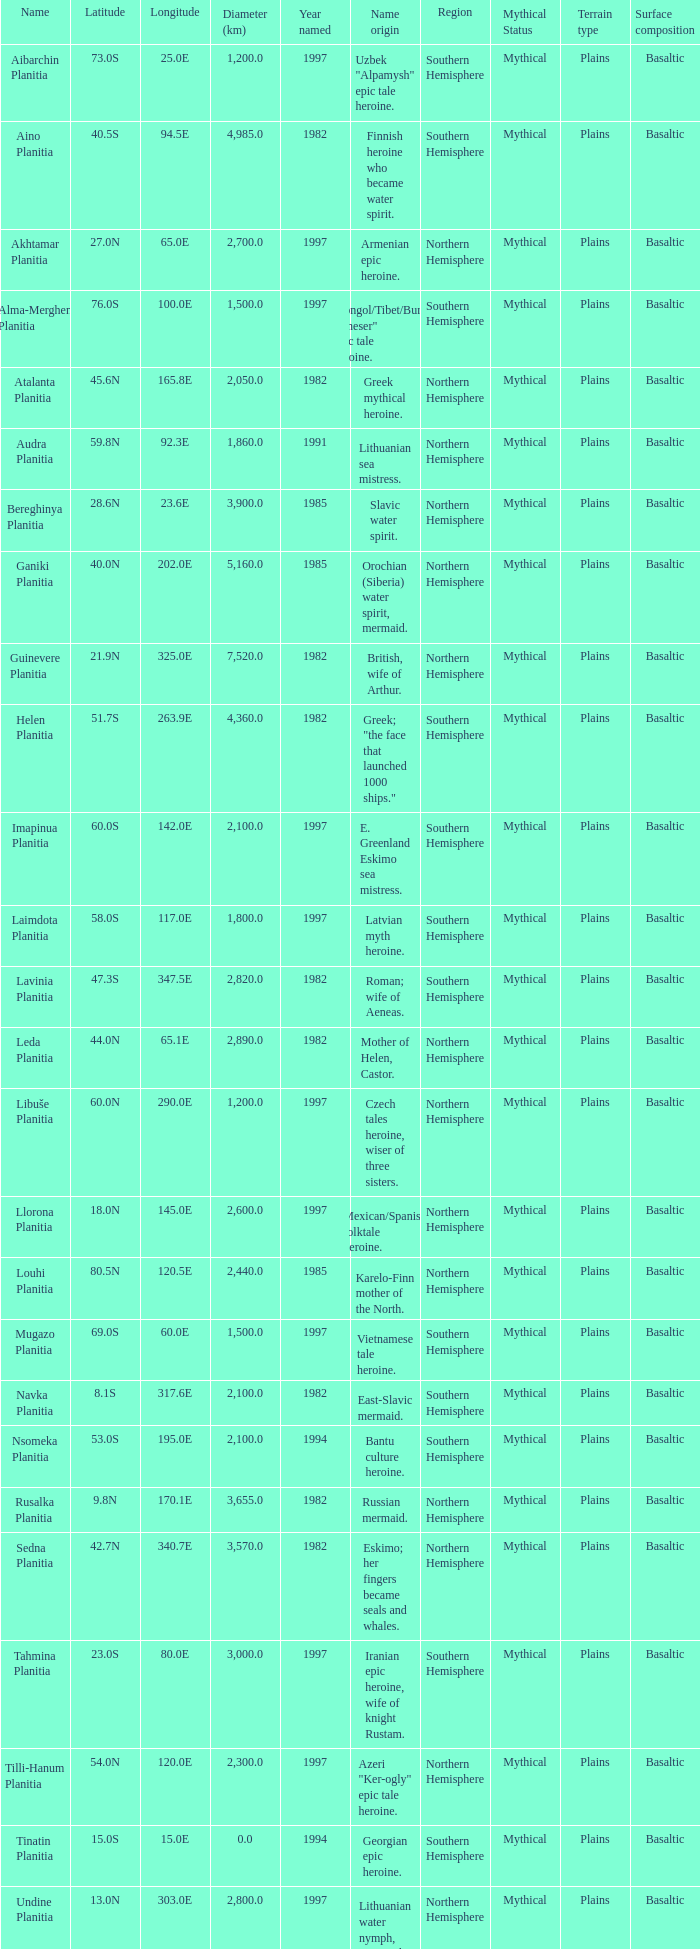What is the diameter (km) of longitude 170.1e 3655.0. 